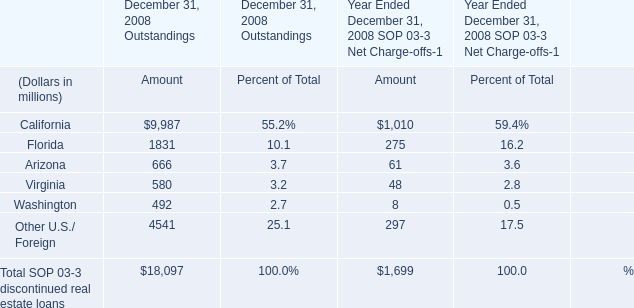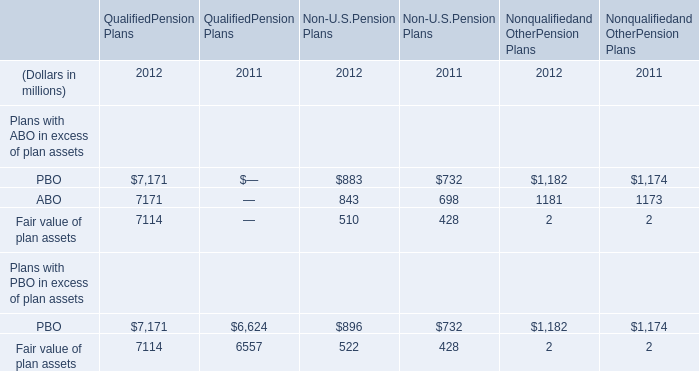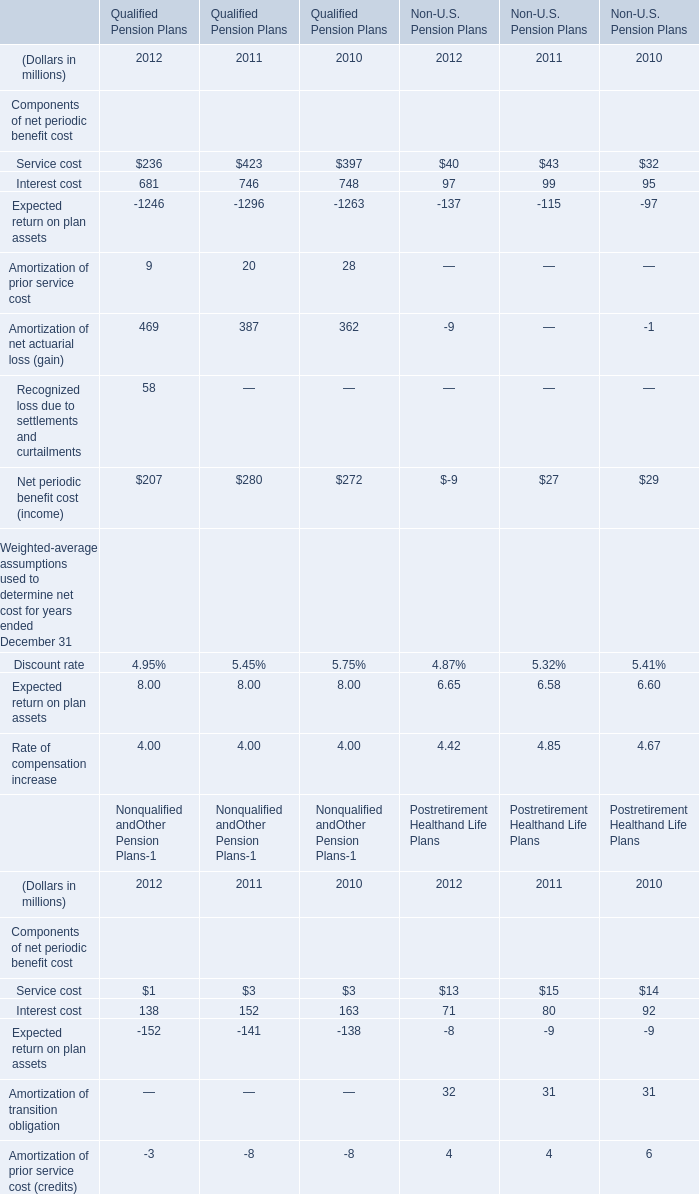What is the sum of PBO of QualifiedPension Plans 2012, Expected return on plan assets of Qualified Pension Plans 2010, and Expected return on plan assets of Qualified Pension Plans 2011 ? 
Computations: ((7171.0 + 1263.0) + 1296.0)
Answer: 9730.0. 